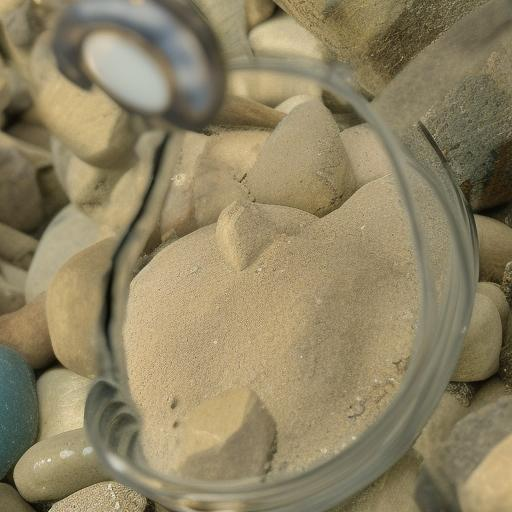What is the color palette of the image? A. colorful B. vibrant C. monotone Answer with the option's letter from the given choices directly. The color palette of the image tends toward 'C. monotone', featuring primarily subtle, earthy tones that range from beige to gray. There is an intriguing play of light and shadow, but the overall chromatic scheme lacks the vividness typically associated with a colorful or vibrant palette. The presence of the magnifying glass introduces a slight distortion, offering a closer view of the fine grains of sand, but it does not significantly alter the largely muted color scheme. 